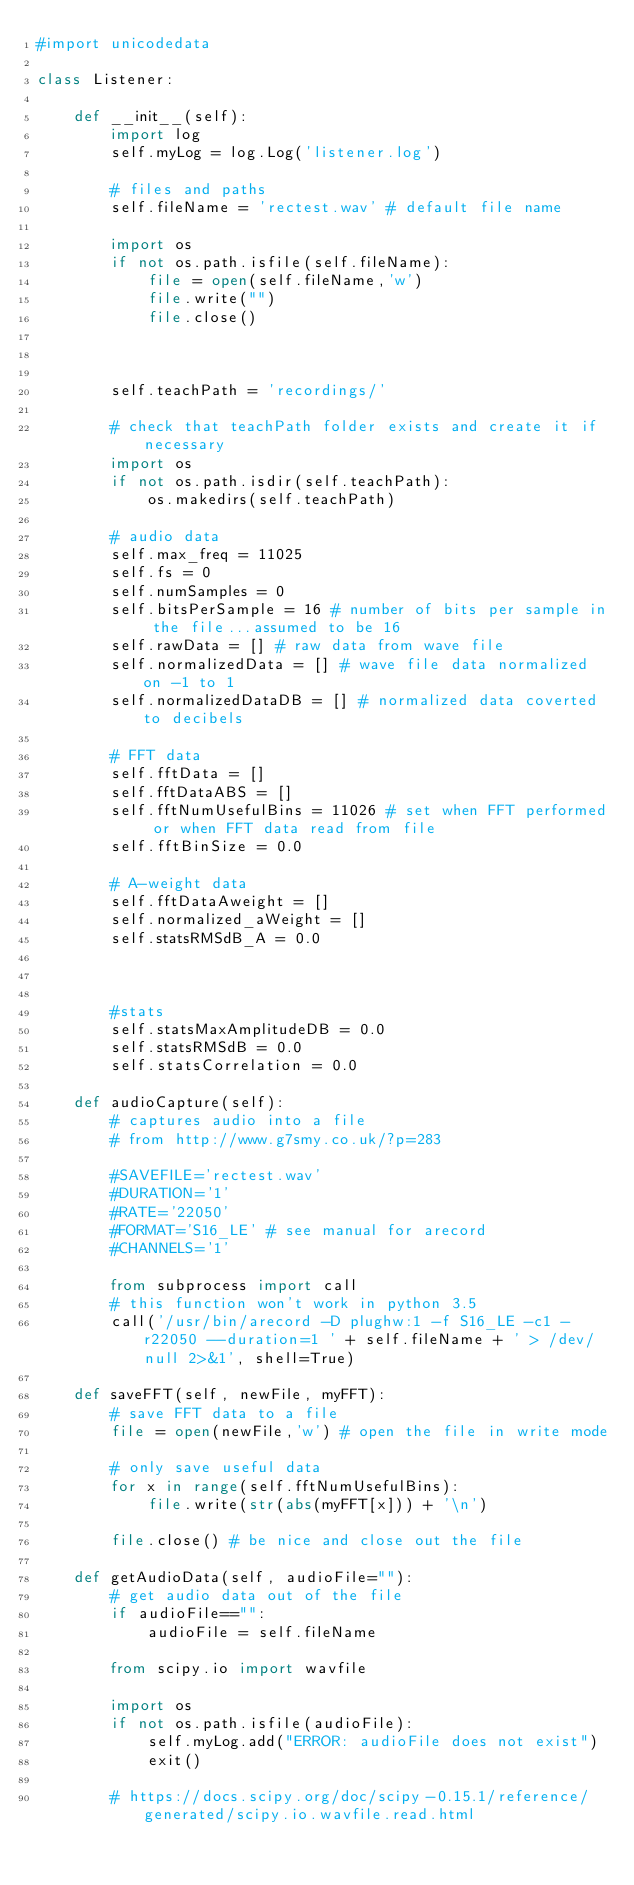<code> <loc_0><loc_0><loc_500><loc_500><_Python_>#import unicodedata

class Listener:

    def __init__(self):
        import log
        self.myLog = log.Log('listener.log')

        # files and paths
        self.fileName = 'rectest.wav' # default file name

        import os
        if not os.path.isfile(self.fileName):
            file = open(self.fileName,'w')
            file.write("")
            file.close()        
        
        
        
        self.teachPath = 'recordings/'

        # check that teachPath folder exists and create it if necessary
        import os
        if not os.path.isdir(self.teachPath):
            os.makedirs(self.teachPath)   

        # audio data        
        self.max_freq = 11025 
        self.fs = 0
        self.numSamples = 0
        self.bitsPerSample = 16 # number of bits per sample in the file...assumed to be 16
        self.rawData = [] # raw data from wave file
        self.normalizedData = [] # wave file data normalized on -1 to 1
        self.normalizedDataDB = [] # normalized data coverted to decibels

        # FFT data
        self.fftData = []
        self.fftDataABS = []
        self.fftNumUsefulBins = 11026 # set when FFT performed or when FFT data read from file
        self.fftBinSize = 0.0

        # A-weight data
        self.fftDataAweight = []
        self.normalized_aWeight = []
        self.statsRMSdB_A = 0.0



        #stats
        self.statsMaxAmplitudeDB = 0.0
        self.statsRMSdB = 0.0
        self.statsCorrelation = 0.0

    def audioCapture(self):
        # captures audio into a file
        # from http://www.g7smy.co.uk/?p=283

        #SAVEFILE='rectest.wav'
        #DURATION='1'
        #RATE='22050'
        #FORMAT='S16_LE' # see manual for arecord
        #CHANNELS='1'

        from subprocess import call
        # this function won't work in python 3.5
        call('/usr/bin/arecord -D plughw:1 -f S16_LE -c1 -r22050 --duration=1 ' + self.fileName + ' > /dev/null 2>&1', shell=True)

    def saveFFT(self, newFile, myFFT):
        # save FFT data to a file
        file = open(newFile,'w') # open the file in write mode
        
        # only save useful data
        for x in range(self.fftNumUsefulBins):
            file.write(str(abs(myFFT[x])) + '\n')
        
        file.close() # be nice and close out the file

    def getAudioData(self, audioFile=""):
        # get audio data out of the file
        if audioFile=="":
            audioFile = self.fileName
            
        from scipy.io import wavfile 

        import os
        if not os.path.isfile(audioFile):
            self.myLog.add("ERROR: audioFile does not exist")
            exit()
            
        # https://docs.scipy.org/doc/scipy-0.15.1/reference/generated/scipy.io.wavfile.read.html</code> 